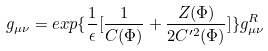Convert formula to latex. <formula><loc_0><loc_0><loc_500><loc_500>g _ { \mu \nu } = e x p \{ \frac { 1 } { \epsilon } [ \frac { 1 } { C ( \Phi ) } + \frac { Z ( \Phi ) } { 2 C ^ { \prime 2 } ( \Phi ) } ] \} g _ { \mu \nu } ^ { R }</formula> 